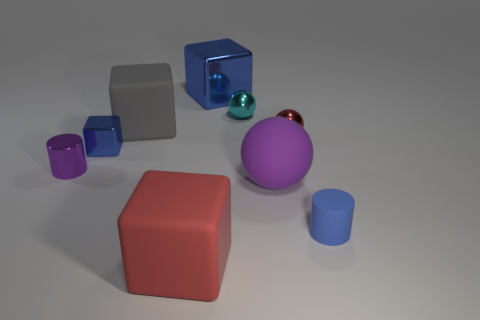There is a small shiny object behind the red ball; are there any blue rubber objects that are to the right of it?
Your response must be concise. Yes. There is a small blue thing that is to the left of the blue rubber object; is its shape the same as the red rubber object?
Provide a short and direct response. Yes. Is there anything else that is the same shape as the cyan metal object?
Your answer should be compact. Yes. How many cylinders are either tiny cyan metal things or small red things?
Provide a short and direct response. 0. What number of brown rubber cubes are there?
Provide a succinct answer. 0. What size is the metallic cube that is behind the small ball on the left side of the red sphere?
Provide a succinct answer. Large. What number of other things are the same size as the cyan thing?
Provide a short and direct response. 4. What number of big gray objects are on the right side of the tiny cyan ball?
Offer a terse response. 0. The red metallic object is what size?
Give a very brief answer. Small. Are the purple object on the left side of the gray matte object and the blue thing on the right side of the large blue thing made of the same material?
Provide a short and direct response. No. 